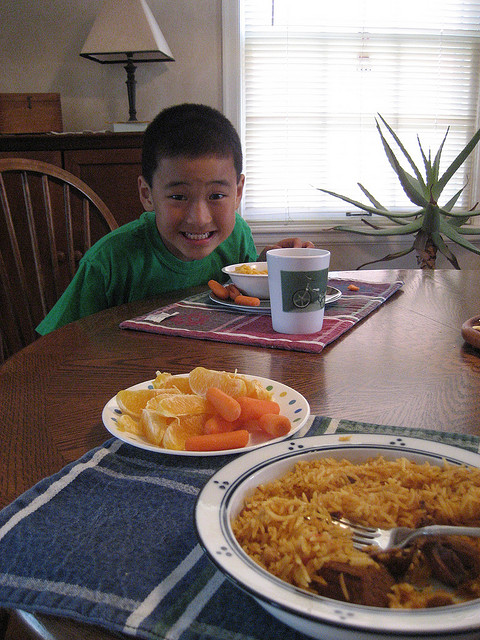<image>What are the white square things on the counter in the background? It is unknown what the white square things on the counter in the background are. They could be napkins, lamp shades, tiles, books, coasters, lamps, plates, or dominoes. What are the white square things on the counter in the background? I don't know what the white square things on the counter in the background are. There are a few possibilities such as napkin, lamp shade, tile, books, coasters, lamps, or plate. 